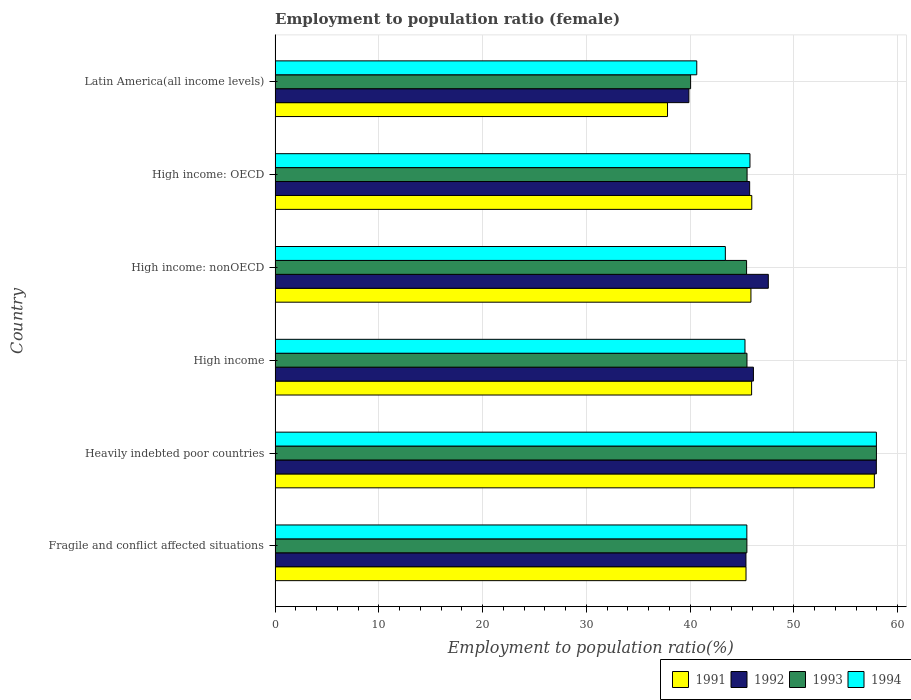How many different coloured bars are there?
Make the answer very short. 4. Are the number of bars on each tick of the Y-axis equal?
Your answer should be compact. Yes. How many bars are there on the 3rd tick from the bottom?
Ensure brevity in your answer.  4. What is the label of the 5th group of bars from the top?
Ensure brevity in your answer.  Heavily indebted poor countries. In how many cases, is the number of bars for a given country not equal to the number of legend labels?
Provide a short and direct response. 0. What is the employment to population ratio in 1992 in High income?
Give a very brief answer. 46.1. Across all countries, what is the maximum employment to population ratio in 1993?
Provide a succinct answer. 57.96. Across all countries, what is the minimum employment to population ratio in 1993?
Keep it short and to the point. 40.05. In which country was the employment to population ratio in 1992 maximum?
Your answer should be compact. Heavily indebted poor countries. In which country was the employment to population ratio in 1993 minimum?
Offer a very short reply. Latin America(all income levels). What is the total employment to population ratio in 1992 in the graph?
Offer a terse response. 282.61. What is the difference between the employment to population ratio in 1993 in High income and that in High income: OECD?
Give a very brief answer. -0.01. What is the difference between the employment to population ratio in 1993 in Latin America(all income levels) and the employment to population ratio in 1991 in Fragile and conflict affected situations?
Your answer should be very brief. -5.34. What is the average employment to population ratio in 1991 per country?
Provide a succinct answer. 46.45. What is the difference between the employment to population ratio in 1991 and employment to population ratio in 1992 in High income?
Offer a terse response. -0.17. What is the ratio of the employment to population ratio in 1991 in Fragile and conflict affected situations to that in Latin America(all income levels)?
Your response must be concise. 1.2. What is the difference between the highest and the second highest employment to population ratio in 1991?
Provide a short and direct response. 11.81. What is the difference between the highest and the lowest employment to population ratio in 1993?
Your answer should be compact. 17.91. In how many countries, is the employment to population ratio in 1992 greater than the average employment to population ratio in 1992 taken over all countries?
Offer a terse response. 2. Is it the case that in every country, the sum of the employment to population ratio in 1992 and employment to population ratio in 1991 is greater than the sum of employment to population ratio in 1993 and employment to population ratio in 1994?
Provide a succinct answer. No. What does the 1st bar from the top in Heavily indebted poor countries represents?
Offer a very short reply. 1994. What does the 2nd bar from the bottom in Fragile and conflict affected situations represents?
Provide a succinct answer. 1992. How many bars are there?
Your response must be concise. 24. Are all the bars in the graph horizontal?
Give a very brief answer. Yes. How many countries are there in the graph?
Ensure brevity in your answer.  6. Are the values on the major ticks of X-axis written in scientific E-notation?
Offer a terse response. No. Does the graph contain any zero values?
Provide a succinct answer. No. Does the graph contain grids?
Provide a short and direct response. Yes. Where does the legend appear in the graph?
Your answer should be very brief. Bottom right. How many legend labels are there?
Give a very brief answer. 4. How are the legend labels stacked?
Ensure brevity in your answer.  Horizontal. What is the title of the graph?
Offer a very short reply. Employment to population ratio (female). What is the Employment to population ratio(%) of 1991 in Fragile and conflict affected situations?
Offer a very short reply. 45.39. What is the Employment to population ratio(%) of 1992 in Fragile and conflict affected situations?
Offer a very short reply. 45.38. What is the Employment to population ratio(%) in 1993 in Fragile and conflict affected situations?
Make the answer very short. 45.48. What is the Employment to population ratio(%) in 1994 in Fragile and conflict affected situations?
Make the answer very short. 45.47. What is the Employment to population ratio(%) in 1991 in Heavily indebted poor countries?
Provide a short and direct response. 57.76. What is the Employment to population ratio(%) in 1992 in Heavily indebted poor countries?
Make the answer very short. 57.95. What is the Employment to population ratio(%) of 1993 in Heavily indebted poor countries?
Offer a very short reply. 57.96. What is the Employment to population ratio(%) of 1994 in Heavily indebted poor countries?
Offer a very short reply. 57.96. What is the Employment to population ratio(%) in 1991 in High income?
Your answer should be very brief. 45.93. What is the Employment to population ratio(%) of 1992 in High income?
Your response must be concise. 46.1. What is the Employment to population ratio(%) in 1993 in High income?
Keep it short and to the point. 45.48. What is the Employment to population ratio(%) of 1994 in High income?
Your answer should be very brief. 45.29. What is the Employment to population ratio(%) in 1991 in High income: nonOECD?
Make the answer very short. 45.86. What is the Employment to population ratio(%) in 1992 in High income: nonOECD?
Offer a very short reply. 47.54. What is the Employment to population ratio(%) in 1993 in High income: nonOECD?
Offer a terse response. 45.44. What is the Employment to population ratio(%) in 1994 in High income: nonOECD?
Your answer should be compact. 43.4. What is the Employment to population ratio(%) of 1991 in High income: OECD?
Give a very brief answer. 45.95. What is the Employment to population ratio(%) of 1992 in High income: OECD?
Your answer should be compact. 45.74. What is the Employment to population ratio(%) of 1993 in High income: OECD?
Keep it short and to the point. 45.49. What is the Employment to population ratio(%) in 1994 in High income: OECD?
Offer a terse response. 45.77. What is the Employment to population ratio(%) of 1991 in Latin America(all income levels)?
Provide a succinct answer. 37.82. What is the Employment to population ratio(%) in 1992 in Latin America(all income levels)?
Your answer should be compact. 39.89. What is the Employment to population ratio(%) in 1993 in Latin America(all income levels)?
Provide a succinct answer. 40.05. What is the Employment to population ratio(%) in 1994 in Latin America(all income levels)?
Your response must be concise. 40.64. Across all countries, what is the maximum Employment to population ratio(%) of 1991?
Offer a terse response. 57.76. Across all countries, what is the maximum Employment to population ratio(%) in 1992?
Offer a terse response. 57.95. Across all countries, what is the maximum Employment to population ratio(%) in 1993?
Offer a terse response. 57.96. Across all countries, what is the maximum Employment to population ratio(%) in 1994?
Your answer should be compact. 57.96. Across all countries, what is the minimum Employment to population ratio(%) in 1991?
Your answer should be compact. 37.82. Across all countries, what is the minimum Employment to population ratio(%) of 1992?
Provide a short and direct response. 39.89. Across all countries, what is the minimum Employment to population ratio(%) of 1993?
Your answer should be very brief. 40.05. Across all countries, what is the minimum Employment to population ratio(%) in 1994?
Ensure brevity in your answer.  40.64. What is the total Employment to population ratio(%) in 1991 in the graph?
Provide a succinct answer. 278.72. What is the total Employment to population ratio(%) in 1992 in the graph?
Provide a short and direct response. 282.61. What is the total Employment to population ratio(%) in 1993 in the graph?
Your answer should be very brief. 279.91. What is the total Employment to population ratio(%) in 1994 in the graph?
Offer a very short reply. 278.53. What is the difference between the Employment to population ratio(%) of 1991 in Fragile and conflict affected situations and that in Heavily indebted poor countries?
Offer a very short reply. -12.37. What is the difference between the Employment to population ratio(%) in 1992 in Fragile and conflict affected situations and that in Heavily indebted poor countries?
Your response must be concise. -12.57. What is the difference between the Employment to population ratio(%) in 1993 in Fragile and conflict affected situations and that in Heavily indebted poor countries?
Give a very brief answer. -12.48. What is the difference between the Employment to population ratio(%) in 1994 in Fragile and conflict affected situations and that in Heavily indebted poor countries?
Offer a very short reply. -12.49. What is the difference between the Employment to population ratio(%) of 1991 in Fragile and conflict affected situations and that in High income?
Offer a terse response. -0.54. What is the difference between the Employment to population ratio(%) of 1992 in Fragile and conflict affected situations and that in High income?
Offer a very short reply. -0.72. What is the difference between the Employment to population ratio(%) in 1993 in Fragile and conflict affected situations and that in High income?
Provide a short and direct response. -0.01. What is the difference between the Employment to population ratio(%) in 1994 in Fragile and conflict affected situations and that in High income?
Give a very brief answer. 0.18. What is the difference between the Employment to population ratio(%) of 1991 in Fragile and conflict affected situations and that in High income: nonOECD?
Offer a very short reply. -0.47. What is the difference between the Employment to population ratio(%) in 1992 in Fragile and conflict affected situations and that in High income: nonOECD?
Your response must be concise. -2.16. What is the difference between the Employment to population ratio(%) in 1993 in Fragile and conflict affected situations and that in High income: nonOECD?
Your answer should be very brief. 0.03. What is the difference between the Employment to population ratio(%) of 1994 in Fragile and conflict affected situations and that in High income: nonOECD?
Keep it short and to the point. 2.07. What is the difference between the Employment to population ratio(%) of 1991 in Fragile and conflict affected situations and that in High income: OECD?
Give a very brief answer. -0.56. What is the difference between the Employment to population ratio(%) of 1992 in Fragile and conflict affected situations and that in High income: OECD?
Ensure brevity in your answer.  -0.36. What is the difference between the Employment to population ratio(%) of 1993 in Fragile and conflict affected situations and that in High income: OECD?
Offer a very short reply. -0.02. What is the difference between the Employment to population ratio(%) in 1994 in Fragile and conflict affected situations and that in High income: OECD?
Give a very brief answer. -0.3. What is the difference between the Employment to population ratio(%) in 1991 in Fragile and conflict affected situations and that in Latin America(all income levels)?
Provide a succinct answer. 7.57. What is the difference between the Employment to population ratio(%) in 1992 in Fragile and conflict affected situations and that in Latin America(all income levels)?
Ensure brevity in your answer.  5.5. What is the difference between the Employment to population ratio(%) in 1993 in Fragile and conflict affected situations and that in Latin America(all income levels)?
Give a very brief answer. 5.42. What is the difference between the Employment to population ratio(%) in 1994 in Fragile and conflict affected situations and that in Latin America(all income levels)?
Make the answer very short. 4.83. What is the difference between the Employment to population ratio(%) in 1991 in Heavily indebted poor countries and that in High income?
Your answer should be very brief. 11.83. What is the difference between the Employment to population ratio(%) in 1992 in Heavily indebted poor countries and that in High income?
Your response must be concise. 11.85. What is the difference between the Employment to population ratio(%) in 1993 in Heavily indebted poor countries and that in High income?
Provide a succinct answer. 12.48. What is the difference between the Employment to population ratio(%) in 1994 in Heavily indebted poor countries and that in High income?
Make the answer very short. 12.67. What is the difference between the Employment to population ratio(%) of 1991 in Heavily indebted poor countries and that in High income: nonOECD?
Provide a short and direct response. 11.9. What is the difference between the Employment to population ratio(%) in 1992 in Heavily indebted poor countries and that in High income: nonOECD?
Provide a succinct answer. 10.41. What is the difference between the Employment to population ratio(%) in 1993 in Heavily indebted poor countries and that in High income: nonOECD?
Offer a terse response. 12.52. What is the difference between the Employment to population ratio(%) of 1994 in Heavily indebted poor countries and that in High income: nonOECD?
Offer a terse response. 14.56. What is the difference between the Employment to population ratio(%) in 1991 in Heavily indebted poor countries and that in High income: OECD?
Offer a very short reply. 11.81. What is the difference between the Employment to population ratio(%) of 1992 in Heavily indebted poor countries and that in High income: OECD?
Your answer should be very brief. 12.21. What is the difference between the Employment to population ratio(%) in 1993 in Heavily indebted poor countries and that in High income: OECD?
Provide a short and direct response. 12.47. What is the difference between the Employment to population ratio(%) in 1994 in Heavily indebted poor countries and that in High income: OECD?
Your answer should be very brief. 12.18. What is the difference between the Employment to population ratio(%) of 1991 in Heavily indebted poor countries and that in Latin America(all income levels)?
Offer a very short reply. 19.94. What is the difference between the Employment to population ratio(%) in 1992 in Heavily indebted poor countries and that in Latin America(all income levels)?
Provide a short and direct response. 18.07. What is the difference between the Employment to population ratio(%) in 1993 in Heavily indebted poor countries and that in Latin America(all income levels)?
Your answer should be very brief. 17.91. What is the difference between the Employment to population ratio(%) of 1994 in Heavily indebted poor countries and that in Latin America(all income levels)?
Make the answer very short. 17.31. What is the difference between the Employment to population ratio(%) of 1991 in High income and that in High income: nonOECD?
Your response must be concise. 0.07. What is the difference between the Employment to population ratio(%) of 1992 in High income and that in High income: nonOECD?
Provide a short and direct response. -1.44. What is the difference between the Employment to population ratio(%) in 1993 in High income and that in High income: nonOECD?
Your response must be concise. 0.04. What is the difference between the Employment to population ratio(%) of 1994 in High income and that in High income: nonOECD?
Provide a short and direct response. 1.89. What is the difference between the Employment to population ratio(%) in 1991 in High income and that in High income: OECD?
Provide a short and direct response. -0.02. What is the difference between the Employment to population ratio(%) of 1992 in High income and that in High income: OECD?
Your answer should be compact. 0.36. What is the difference between the Employment to population ratio(%) of 1993 in High income and that in High income: OECD?
Keep it short and to the point. -0.01. What is the difference between the Employment to population ratio(%) in 1994 in High income and that in High income: OECD?
Your answer should be very brief. -0.48. What is the difference between the Employment to population ratio(%) in 1991 in High income and that in Latin America(all income levels)?
Ensure brevity in your answer.  8.11. What is the difference between the Employment to population ratio(%) in 1992 in High income and that in Latin America(all income levels)?
Provide a succinct answer. 6.22. What is the difference between the Employment to population ratio(%) of 1993 in High income and that in Latin America(all income levels)?
Ensure brevity in your answer.  5.43. What is the difference between the Employment to population ratio(%) of 1994 in High income and that in Latin America(all income levels)?
Ensure brevity in your answer.  4.65. What is the difference between the Employment to population ratio(%) of 1991 in High income: nonOECD and that in High income: OECD?
Your answer should be compact. -0.08. What is the difference between the Employment to population ratio(%) of 1992 in High income: nonOECD and that in High income: OECD?
Provide a short and direct response. 1.8. What is the difference between the Employment to population ratio(%) of 1993 in High income: nonOECD and that in High income: OECD?
Provide a succinct answer. -0.05. What is the difference between the Employment to population ratio(%) of 1994 in High income: nonOECD and that in High income: OECD?
Provide a short and direct response. -2.37. What is the difference between the Employment to population ratio(%) in 1991 in High income: nonOECD and that in Latin America(all income levels)?
Give a very brief answer. 8.04. What is the difference between the Employment to population ratio(%) in 1992 in High income: nonOECD and that in Latin America(all income levels)?
Offer a very short reply. 7.65. What is the difference between the Employment to population ratio(%) of 1993 in High income: nonOECD and that in Latin America(all income levels)?
Ensure brevity in your answer.  5.39. What is the difference between the Employment to population ratio(%) in 1994 in High income: nonOECD and that in Latin America(all income levels)?
Your answer should be compact. 2.75. What is the difference between the Employment to population ratio(%) of 1991 in High income: OECD and that in Latin America(all income levels)?
Ensure brevity in your answer.  8.12. What is the difference between the Employment to population ratio(%) in 1992 in High income: OECD and that in Latin America(all income levels)?
Make the answer very short. 5.86. What is the difference between the Employment to population ratio(%) of 1993 in High income: OECD and that in Latin America(all income levels)?
Your answer should be very brief. 5.44. What is the difference between the Employment to population ratio(%) of 1994 in High income: OECD and that in Latin America(all income levels)?
Your answer should be compact. 5.13. What is the difference between the Employment to population ratio(%) in 1991 in Fragile and conflict affected situations and the Employment to population ratio(%) in 1992 in Heavily indebted poor countries?
Ensure brevity in your answer.  -12.56. What is the difference between the Employment to population ratio(%) of 1991 in Fragile and conflict affected situations and the Employment to population ratio(%) of 1993 in Heavily indebted poor countries?
Your response must be concise. -12.57. What is the difference between the Employment to population ratio(%) of 1991 in Fragile and conflict affected situations and the Employment to population ratio(%) of 1994 in Heavily indebted poor countries?
Make the answer very short. -12.57. What is the difference between the Employment to population ratio(%) of 1992 in Fragile and conflict affected situations and the Employment to population ratio(%) of 1993 in Heavily indebted poor countries?
Provide a succinct answer. -12.58. What is the difference between the Employment to population ratio(%) of 1992 in Fragile and conflict affected situations and the Employment to population ratio(%) of 1994 in Heavily indebted poor countries?
Offer a very short reply. -12.57. What is the difference between the Employment to population ratio(%) in 1993 in Fragile and conflict affected situations and the Employment to population ratio(%) in 1994 in Heavily indebted poor countries?
Your answer should be very brief. -12.48. What is the difference between the Employment to population ratio(%) of 1991 in Fragile and conflict affected situations and the Employment to population ratio(%) of 1992 in High income?
Your response must be concise. -0.71. What is the difference between the Employment to population ratio(%) of 1991 in Fragile and conflict affected situations and the Employment to population ratio(%) of 1993 in High income?
Ensure brevity in your answer.  -0.09. What is the difference between the Employment to population ratio(%) in 1991 in Fragile and conflict affected situations and the Employment to population ratio(%) in 1994 in High income?
Provide a short and direct response. 0.1. What is the difference between the Employment to population ratio(%) of 1992 in Fragile and conflict affected situations and the Employment to population ratio(%) of 1993 in High income?
Your response must be concise. -0.1. What is the difference between the Employment to population ratio(%) in 1992 in Fragile and conflict affected situations and the Employment to population ratio(%) in 1994 in High income?
Ensure brevity in your answer.  0.09. What is the difference between the Employment to population ratio(%) in 1993 in Fragile and conflict affected situations and the Employment to population ratio(%) in 1994 in High income?
Offer a terse response. 0.18. What is the difference between the Employment to population ratio(%) in 1991 in Fragile and conflict affected situations and the Employment to population ratio(%) in 1992 in High income: nonOECD?
Your response must be concise. -2.15. What is the difference between the Employment to population ratio(%) in 1991 in Fragile and conflict affected situations and the Employment to population ratio(%) in 1993 in High income: nonOECD?
Make the answer very short. -0.05. What is the difference between the Employment to population ratio(%) in 1991 in Fragile and conflict affected situations and the Employment to population ratio(%) in 1994 in High income: nonOECD?
Offer a terse response. 1.99. What is the difference between the Employment to population ratio(%) in 1992 in Fragile and conflict affected situations and the Employment to population ratio(%) in 1993 in High income: nonOECD?
Make the answer very short. -0.06. What is the difference between the Employment to population ratio(%) of 1992 in Fragile and conflict affected situations and the Employment to population ratio(%) of 1994 in High income: nonOECD?
Give a very brief answer. 1.99. What is the difference between the Employment to population ratio(%) of 1993 in Fragile and conflict affected situations and the Employment to population ratio(%) of 1994 in High income: nonOECD?
Offer a terse response. 2.08. What is the difference between the Employment to population ratio(%) in 1991 in Fragile and conflict affected situations and the Employment to population ratio(%) in 1992 in High income: OECD?
Offer a terse response. -0.35. What is the difference between the Employment to population ratio(%) in 1991 in Fragile and conflict affected situations and the Employment to population ratio(%) in 1993 in High income: OECD?
Provide a short and direct response. -0.1. What is the difference between the Employment to population ratio(%) of 1991 in Fragile and conflict affected situations and the Employment to population ratio(%) of 1994 in High income: OECD?
Your response must be concise. -0.38. What is the difference between the Employment to population ratio(%) of 1992 in Fragile and conflict affected situations and the Employment to population ratio(%) of 1993 in High income: OECD?
Give a very brief answer. -0.11. What is the difference between the Employment to population ratio(%) in 1992 in Fragile and conflict affected situations and the Employment to population ratio(%) in 1994 in High income: OECD?
Ensure brevity in your answer.  -0.39. What is the difference between the Employment to population ratio(%) in 1993 in Fragile and conflict affected situations and the Employment to population ratio(%) in 1994 in High income: OECD?
Give a very brief answer. -0.3. What is the difference between the Employment to population ratio(%) in 1991 in Fragile and conflict affected situations and the Employment to population ratio(%) in 1992 in Latin America(all income levels)?
Your answer should be compact. 5.51. What is the difference between the Employment to population ratio(%) of 1991 in Fragile and conflict affected situations and the Employment to population ratio(%) of 1993 in Latin America(all income levels)?
Offer a terse response. 5.34. What is the difference between the Employment to population ratio(%) in 1991 in Fragile and conflict affected situations and the Employment to population ratio(%) in 1994 in Latin America(all income levels)?
Offer a terse response. 4.75. What is the difference between the Employment to population ratio(%) of 1992 in Fragile and conflict affected situations and the Employment to population ratio(%) of 1993 in Latin America(all income levels)?
Keep it short and to the point. 5.33. What is the difference between the Employment to population ratio(%) of 1992 in Fragile and conflict affected situations and the Employment to population ratio(%) of 1994 in Latin America(all income levels)?
Give a very brief answer. 4.74. What is the difference between the Employment to population ratio(%) of 1993 in Fragile and conflict affected situations and the Employment to population ratio(%) of 1994 in Latin America(all income levels)?
Ensure brevity in your answer.  4.83. What is the difference between the Employment to population ratio(%) of 1991 in Heavily indebted poor countries and the Employment to population ratio(%) of 1992 in High income?
Give a very brief answer. 11.66. What is the difference between the Employment to population ratio(%) in 1991 in Heavily indebted poor countries and the Employment to population ratio(%) in 1993 in High income?
Your answer should be compact. 12.28. What is the difference between the Employment to population ratio(%) of 1991 in Heavily indebted poor countries and the Employment to population ratio(%) of 1994 in High income?
Give a very brief answer. 12.47. What is the difference between the Employment to population ratio(%) of 1992 in Heavily indebted poor countries and the Employment to population ratio(%) of 1993 in High income?
Your response must be concise. 12.47. What is the difference between the Employment to population ratio(%) in 1992 in Heavily indebted poor countries and the Employment to population ratio(%) in 1994 in High income?
Offer a terse response. 12.66. What is the difference between the Employment to population ratio(%) in 1993 in Heavily indebted poor countries and the Employment to population ratio(%) in 1994 in High income?
Make the answer very short. 12.67. What is the difference between the Employment to population ratio(%) in 1991 in Heavily indebted poor countries and the Employment to population ratio(%) in 1992 in High income: nonOECD?
Offer a very short reply. 10.22. What is the difference between the Employment to population ratio(%) in 1991 in Heavily indebted poor countries and the Employment to population ratio(%) in 1993 in High income: nonOECD?
Provide a succinct answer. 12.32. What is the difference between the Employment to population ratio(%) of 1991 in Heavily indebted poor countries and the Employment to population ratio(%) of 1994 in High income: nonOECD?
Offer a very short reply. 14.36. What is the difference between the Employment to population ratio(%) of 1992 in Heavily indebted poor countries and the Employment to population ratio(%) of 1993 in High income: nonOECD?
Provide a short and direct response. 12.51. What is the difference between the Employment to population ratio(%) of 1992 in Heavily indebted poor countries and the Employment to population ratio(%) of 1994 in High income: nonOECD?
Your answer should be compact. 14.55. What is the difference between the Employment to population ratio(%) in 1993 in Heavily indebted poor countries and the Employment to population ratio(%) in 1994 in High income: nonOECD?
Provide a short and direct response. 14.56. What is the difference between the Employment to population ratio(%) of 1991 in Heavily indebted poor countries and the Employment to population ratio(%) of 1992 in High income: OECD?
Provide a succinct answer. 12.02. What is the difference between the Employment to population ratio(%) in 1991 in Heavily indebted poor countries and the Employment to population ratio(%) in 1993 in High income: OECD?
Your answer should be very brief. 12.27. What is the difference between the Employment to population ratio(%) in 1991 in Heavily indebted poor countries and the Employment to population ratio(%) in 1994 in High income: OECD?
Your answer should be compact. 11.99. What is the difference between the Employment to population ratio(%) of 1992 in Heavily indebted poor countries and the Employment to population ratio(%) of 1993 in High income: OECD?
Provide a succinct answer. 12.46. What is the difference between the Employment to population ratio(%) of 1992 in Heavily indebted poor countries and the Employment to population ratio(%) of 1994 in High income: OECD?
Your response must be concise. 12.18. What is the difference between the Employment to population ratio(%) in 1993 in Heavily indebted poor countries and the Employment to population ratio(%) in 1994 in High income: OECD?
Give a very brief answer. 12.19. What is the difference between the Employment to population ratio(%) in 1991 in Heavily indebted poor countries and the Employment to population ratio(%) in 1992 in Latin America(all income levels)?
Make the answer very short. 17.88. What is the difference between the Employment to population ratio(%) in 1991 in Heavily indebted poor countries and the Employment to population ratio(%) in 1993 in Latin America(all income levels)?
Your response must be concise. 17.71. What is the difference between the Employment to population ratio(%) in 1991 in Heavily indebted poor countries and the Employment to population ratio(%) in 1994 in Latin America(all income levels)?
Provide a short and direct response. 17.12. What is the difference between the Employment to population ratio(%) in 1992 in Heavily indebted poor countries and the Employment to population ratio(%) in 1993 in Latin America(all income levels)?
Offer a terse response. 17.9. What is the difference between the Employment to population ratio(%) in 1992 in Heavily indebted poor countries and the Employment to population ratio(%) in 1994 in Latin America(all income levels)?
Provide a short and direct response. 17.31. What is the difference between the Employment to population ratio(%) of 1993 in Heavily indebted poor countries and the Employment to population ratio(%) of 1994 in Latin America(all income levels)?
Your answer should be compact. 17.32. What is the difference between the Employment to population ratio(%) in 1991 in High income and the Employment to population ratio(%) in 1992 in High income: nonOECD?
Your answer should be compact. -1.61. What is the difference between the Employment to population ratio(%) in 1991 in High income and the Employment to population ratio(%) in 1993 in High income: nonOECD?
Offer a very short reply. 0.49. What is the difference between the Employment to population ratio(%) in 1991 in High income and the Employment to population ratio(%) in 1994 in High income: nonOECD?
Offer a terse response. 2.53. What is the difference between the Employment to population ratio(%) in 1992 in High income and the Employment to population ratio(%) in 1993 in High income: nonOECD?
Make the answer very short. 0.66. What is the difference between the Employment to population ratio(%) of 1992 in High income and the Employment to population ratio(%) of 1994 in High income: nonOECD?
Your answer should be very brief. 2.71. What is the difference between the Employment to population ratio(%) of 1993 in High income and the Employment to population ratio(%) of 1994 in High income: nonOECD?
Your response must be concise. 2.09. What is the difference between the Employment to population ratio(%) in 1991 in High income and the Employment to population ratio(%) in 1992 in High income: OECD?
Offer a very short reply. 0.19. What is the difference between the Employment to population ratio(%) in 1991 in High income and the Employment to population ratio(%) in 1993 in High income: OECD?
Make the answer very short. 0.44. What is the difference between the Employment to population ratio(%) in 1991 in High income and the Employment to population ratio(%) in 1994 in High income: OECD?
Offer a terse response. 0.16. What is the difference between the Employment to population ratio(%) in 1992 in High income and the Employment to population ratio(%) in 1993 in High income: OECD?
Your response must be concise. 0.61. What is the difference between the Employment to population ratio(%) of 1992 in High income and the Employment to population ratio(%) of 1994 in High income: OECD?
Your response must be concise. 0.33. What is the difference between the Employment to population ratio(%) in 1993 in High income and the Employment to population ratio(%) in 1994 in High income: OECD?
Offer a terse response. -0.29. What is the difference between the Employment to population ratio(%) in 1991 in High income and the Employment to population ratio(%) in 1992 in Latin America(all income levels)?
Offer a terse response. 6.05. What is the difference between the Employment to population ratio(%) in 1991 in High income and the Employment to population ratio(%) in 1993 in Latin America(all income levels)?
Offer a terse response. 5.88. What is the difference between the Employment to population ratio(%) of 1991 in High income and the Employment to population ratio(%) of 1994 in Latin America(all income levels)?
Offer a terse response. 5.29. What is the difference between the Employment to population ratio(%) of 1992 in High income and the Employment to population ratio(%) of 1993 in Latin America(all income levels)?
Your response must be concise. 6.05. What is the difference between the Employment to population ratio(%) of 1992 in High income and the Employment to population ratio(%) of 1994 in Latin America(all income levels)?
Your response must be concise. 5.46. What is the difference between the Employment to population ratio(%) in 1993 in High income and the Employment to population ratio(%) in 1994 in Latin America(all income levels)?
Provide a succinct answer. 4.84. What is the difference between the Employment to population ratio(%) in 1991 in High income: nonOECD and the Employment to population ratio(%) in 1992 in High income: OECD?
Your response must be concise. 0.12. What is the difference between the Employment to population ratio(%) of 1991 in High income: nonOECD and the Employment to population ratio(%) of 1993 in High income: OECD?
Your response must be concise. 0.37. What is the difference between the Employment to population ratio(%) of 1991 in High income: nonOECD and the Employment to population ratio(%) of 1994 in High income: OECD?
Provide a short and direct response. 0.09. What is the difference between the Employment to population ratio(%) of 1992 in High income: nonOECD and the Employment to population ratio(%) of 1993 in High income: OECD?
Offer a terse response. 2.05. What is the difference between the Employment to population ratio(%) of 1992 in High income: nonOECD and the Employment to population ratio(%) of 1994 in High income: OECD?
Offer a terse response. 1.77. What is the difference between the Employment to population ratio(%) in 1993 in High income: nonOECD and the Employment to population ratio(%) in 1994 in High income: OECD?
Keep it short and to the point. -0.33. What is the difference between the Employment to population ratio(%) in 1991 in High income: nonOECD and the Employment to population ratio(%) in 1992 in Latin America(all income levels)?
Ensure brevity in your answer.  5.98. What is the difference between the Employment to population ratio(%) in 1991 in High income: nonOECD and the Employment to population ratio(%) in 1993 in Latin America(all income levels)?
Provide a succinct answer. 5.81. What is the difference between the Employment to population ratio(%) in 1991 in High income: nonOECD and the Employment to population ratio(%) in 1994 in Latin America(all income levels)?
Provide a succinct answer. 5.22. What is the difference between the Employment to population ratio(%) in 1992 in High income: nonOECD and the Employment to population ratio(%) in 1993 in Latin America(all income levels)?
Offer a terse response. 7.49. What is the difference between the Employment to population ratio(%) of 1992 in High income: nonOECD and the Employment to population ratio(%) of 1994 in Latin America(all income levels)?
Offer a very short reply. 6.9. What is the difference between the Employment to population ratio(%) of 1993 in High income: nonOECD and the Employment to population ratio(%) of 1994 in Latin America(all income levels)?
Your answer should be very brief. 4.8. What is the difference between the Employment to population ratio(%) of 1991 in High income: OECD and the Employment to population ratio(%) of 1992 in Latin America(all income levels)?
Your response must be concise. 6.06. What is the difference between the Employment to population ratio(%) of 1991 in High income: OECD and the Employment to population ratio(%) of 1993 in Latin America(all income levels)?
Offer a very short reply. 5.9. What is the difference between the Employment to population ratio(%) of 1991 in High income: OECD and the Employment to population ratio(%) of 1994 in Latin America(all income levels)?
Keep it short and to the point. 5.3. What is the difference between the Employment to population ratio(%) in 1992 in High income: OECD and the Employment to population ratio(%) in 1993 in Latin America(all income levels)?
Provide a succinct answer. 5.69. What is the difference between the Employment to population ratio(%) in 1992 in High income: OECD and the Employment to population ratio(%) in 1994 in Latin America(all income levels)?
Provide a short and direct response. 5.1. What is the difference between the Employment to population ratio(%) of 1993 in High income: OECD and the Employment to population ratio(%) of 1994 in Latin America(all income levels)?
Make the answer very short. 4.85. What is the average Employment to population ratio(%) in 1991 per country?
Provide a short and direct response. 46.45. What is the average Employment to population ratio(%) of 1992 per country?
Your answer should be compact. 47.1. What is the average Employment to population ratio(%) in 1993 per country?
Your response must be concise. 46.65. What is the average Employment to population ratio(%) in 1994 per country?
Provide a succinct answer. 46.42. What is the difference between the Employment to population ratio(%) of 1991 and Employment to population ratio(%) of 1992 in Fragile and conflict affected situations?
Your response must be concise. 0.01. What is the difference between the Employment to population ratio(%) in 1991 and Employment to population ratio(%) in 1993 in Fragile and conflict affected situations?
Keep it short and to the point. -0.08. What is the difference between the Employment to population ratio(%) in 1991 and Employment to population ratio(%) in 1994 in Fragile and conflict affected situations?
Make the answer very short. -0.08. What is the difference between the Employment to population ratio(%) of 1992 and Employment to population ratio(%) of 1993 in Fragile and conflict affected situations?
Your answer should be compact. -0.09. What is the difference between the Employment to population ratio(%) of 1992 and Employment to population ratio(%) of 1994 in Fragile and conflict affected situations?
Your response must be concise. -0.09. What is the difference between the Employment to population ratio(%) of 1993 and Employment to population ratio(%) of 1994 in Fragile and conflict affected situations?
Your answer should be very brief. 0.01. What is the difference between the Employment to population ratio(%) of 1991 and Employment to population ratio(%) of 1992 in Heavily indebted poor countries?
Your response must be concise. -0.19. What is the difference between the Employment to population ratio(%) in 1991 and Employment to population ratio(%) in 1993 in Heavily indebted poor countries?
Offer a terse response. -0.2. What is the difference between the Employment to population ratio(%) of 1991 and Employment to population ratio(%) of 1994 in Heavily indebted poor countries?
Your answer should be compact. -0.2. What is the difference between the Employment to population ratio(%) of 1992 and Employment to population ratio(%) of 1993 in Heavily indebted poor countries?
Your answer should be compact. -0.01. What is the difference between the Employment to population ratio(%) in 1992 and Employment to population ratio(%) in 1994 in Heavily indebted poor countries?
Offer a very short reply. -0. What is the difference between the Employment to population ratio(%) in 1993 and Employment to population ratio(%) in 1994 in Heavily indebted poor countries?
Give a very brief answer. 0. What is the difference between the Employment to population ratio(%) of 1991 and Employment to population ratio(%) of 1992 in High income?
Your answer should be very brief. -0.17. What is the difference between the Employment to population ratio(%) in 1991 and Employment to population ratio(%) in 1993 in High income?
Your answer should be very brief. 0.45. What is the difference between the Employment to population ratio(%) in 1991 and Employment to population ratio(%) in 1994 in High income?
Offer a terse response. 0.64. What is the difference between the Employment to population ratio(%) in 1992 and Employment to population ratio(%) in 1993 in High income?
Offer a very short reply. 0.62. What is the difference between the Employment to population ratio(%) of 1992 and Employment to population ratio(%) of 1994 in High income?
Offer a very short reply. 0.81. What is the difference between the Employment to population ratio(%) of 1993 and Employment to population ratio(%) of 1994 in High income?
Keep it short and to the point. 0.19. What is the difference between the Employment to population ratio(%) of 1991 and Employment to population ratio(%) of 1992 in High income: nonOECD?
Your answer should be compact. -1.68. What is the difference between the Employment to population ratio(%) in 1991 and Employment to population ratio(%) in 1993 in High income: nonOECD?
Your answer should be very brief. 0.42. What is the difference between the Employment to population ratio(%) in 1991 and Employment to population ratio(%) in 1994 in High income: nonOECD?
Offer a terse response. 2.47. What is the difference between the Employment to population ratio(%) in 1992 and Employment to population ratio(%) in 1993 in High income: nonOECD?
Make the answer very short. 2.1. What is the difference between the Employment to population ratio(%) of 1992 and Employment to population ratio(%) of 1994 in High income: nonOECD?
Keep it short and to the point. 4.14. What is the difference between the Employment to population ratio(%) in 1993 and Employment to population ratio(%) in 1994 in High income: nonOECD?
Make the answer very short. 2.05. What is the difference between the Employment to population ratio(%) in 1991 and Employment to population ratio(%) in 1992 in High income: OECD?
Provide a succinct answer. 0.21. What is the difference between the Employment to population ratio(%) of 1991 and Employment to population ratio(%) of 1993 in High income: OECD?
Keep it short and to the point. 0.45. What is the difference between the Employment to population ratio(%) of 1991 and Employment to population ratio(%) of 1994 in High income: OECD?
Make the answer very short. 0.17. What is the difference between the Employment to population ratio(%) of 1992 and Employment to population ratio(%) of 1993 in High income: OECD?
Your response must be concise. 0.25. What is the difference between the Employment to population ratio(%) in 1992 and Employment to population ratio(%) in 1994 in High income: OECD?
Make the answer very short. -0.03. What is the difference between the Employment to population ratio(%) in 1993 and Employment to population ratio(%) in 1994 in High income: OECD?
Your response must be concise. -0.28. What is the difference between the Employment to population ratio(%) of 1991 and Employment to population ratio(%) of 1992 in Latin America(all income levels)?
Ensure brevity in your answer.  -2.06. What is the difference between the Employment to population ratio(%) of 1991 and Employment to population ratio(%) of 1993 in Latin America(all income levels)?
Keep it short and to the point. -2.23. What is the difference between the Employment to population ratio(%) in 1991 and Employment to population ratio(%) in 1994 in Latin America(all income levels)?
Your answer should be compact. -2.82. What is the difference between the Employment to population ratio(%) in 1992 and Employment to population ratio(%) in 1993 in Latin America(all income levels)?
Your answer should be compact. -0.17. What is the difference between the Employment to population ratio(%) of 1992 and Employment to population ratio(%) of 1994 in Latin America(all income levels)?
Keep it short and to the point. -0.76. What is the difference between the Employment to population ratio(%) in 1993 and Employment to population ratio(%) in 1994 in Latin America(all income levels)?
Your answer should be compact. -0.59. What is the ratio of the Employment to population ratio(%) in 1991 in Fragile and conflict affected situations to that in Heavily indebted poor countries?
Provide a short and direct response. 0.79. What is the ratio of the Employment to population ratio(%) of 1992 in Fragile and conflict affected situations to that in Heavily indebted poor countries?
Make the answer very short. 0.78. What is the ratio of the Employment to population ratio(%) in 1993 in Fragile and conflict affected situations to that in Heavily indebted poor countries?
Provide a succinct answer. 0.78. What is the ratio of the Employment to population ratio(%) of 1994 in Fragile and conflict affected situations to that in Heavily indebted poor countries?
Your answer should be very brief. 0.78. What is the ratio of the Employment to population ratio(%) of 1992 in Fragile and conflict affected situations to that in High income?
Give a very brief answer. 0.98. What is the ratio of the Employment to population ratio(%) of 1992 in Fragile and conflict affected situations to that in High income: nonOECD?
Your response must be concise. 0.95. What is the ratio of the Employment to population ratio(%) in 1994 in Fragile and conflict affected situations to that in High income: nonOECD?
Keep it short and to the point. 1.05. What is the ratio of the Employment to population ratio(%) in 1991 in Fragile and conflict affected situations to that in High income: OECD?
Keep it short and to the point. 0.99. What is the ratio of the Employment to population ratio(%) in 1993 in Fragile and conflict affected situations to that in High income: OECD?
Keep it short and to the point. 1. What is the ratio of the Employment to population ratio(%) in 1991 in Fragile and conflict affected situations to that in Latin America(all income levels)?
Your answer should be very brief. 1.2. What is the ratio of the Employment to population ratio(%) in 1992 in Fragile and conflict affected situations to that in Latin America(all income levels)?
Keep it short and to the point. 1.14. What is the ratio of the Employment to population ratio(%) in 1993 in Fragile and conflict affected situations to that in Latin America(all income levels)?
Your answer should be compact. 1.14. What is the ratio of the Employment to population ratio(%) of 1994 in Fragile and conflict affected situations to that in Latin America(all income levels)?
Make the answer very short. 1.12. What is the ratio of the Employment to population ratio(%) in 1991 in Heavily indebted poor countries to that in High income?
Give a very brief answer. 1.26. What is the ratio of the Employment to population ratio(%) in 1992 in Heavily indebted poor countries to that in High income?
Provide a short and direct response. 1.26. What is the ratio of the Employment to population ratio(%) of 1993 in Heavily indebted poor countries to that in High income?
Offer a terse response. 1.27. What is the ratio of the Employment to population ratio(%) of 1994 in Heavily indebted poor countries to that in High income?
Ensure brevity in your answer.  1.28. What is the ratio of the Employment to population ratio(%) of 1991 in Heavily indebted poor countries to that in High income: nonOECD?
Keep it short and to the point. 1.26. What is the ratio of the Employment to population ratio(%) of 1992 in Heavily indebted poor countries to that in High income: nonOECD?
Provide a succinct answer. 1.22. What is the ratio of the Employment to population ratio(%) in 1993 in Heavily indebted poor countries to that in High income: nonOECD?
Provide a short and direct response. 1.28. What is the ratio of the Employment to population ratio(%) in 1994 in Heavily indebted poor countries to that in High income: nonOECD?
Provide a succinct answer. 1.34. What is the ratio of the Employment to population ratio(%) of 1991 in Heavily indebted poor countries to that in High income: OECD?
Your answer should be very brief. 1.26. What is the ratio of the Employment to population ratio(%) of 1992 in Heavily indebted poor countries to that in High income: OECD?
Ensure brevity in your answer.  1.27. What is the ratio of the Employment to population ratio(%) of 1993 in Heavily indebted poor countries to that in High income: OECD?
Offer a terse response. 1.27. What is the ratio of the Employment to population ratio(%) in 1994 in Heavily indebted poor countries to that in High income: OECD?
Give a very brief answer. 1.27. What is the ratio of the Employment to population ratio(%) of 1991 in Heavily indebted poor countries to that in Latin America(all income levels)?
Your response must be concise. 1.53. What is the ratio of the Employment to population ratio(%) of 1992 in Heavily indebted poor countries to that in Latin America(all income levels)?
Ensure brevity in your answer.  1.45. What is the ratio of the Employment to population ratio(%) of 1993 in Heavily indebted poor countries to that in Latin America(all income levels)?
Provide a succinct answer. 1.45. What is the ratio of the Employment to population ratio(%) of 1994 in Heavily indebted poor countries to that in Latin America(all income levels)?
Offer a terse response. 1.43. What is the ratio of the Employment to population ratio(%) in 1992 in High income to that in High income: nonOECD?
Give a very brief answer. 0.97. What is the ratio of the Employment to population ratio(%) of 1993 in High income to that in High income: nonOECD?
Provide a short and direct response. 1. What is the ratio of the Employment to population ratio(%) of 1994 in High income to that in High income: nonOECD?
Give a very brief answer. 1.04. What is the ratio of the Employment to population ratio(%) in 1992 in High income to that in High income: OECD?
Offer a terse response. 1.01. What is the ratio of the Employment to population ratio(%) of 1993 in High income to that in High income: OECD?
Provide a succinct answer. 1. What is the ratio of the Employment to population ratio(%) of 1991 in High income to that in Latin America(all income levels)?
Keep it short and to the point. 1.21. What is the ratio of the Employment to population ratio(%) of 1992 in High income to that in Latin America(all income levels)?
Offer a very short reply. 1.16. What is the ratio of the Employment to population ratio(%) in 1993 in High income to that in Latin America(all income levels)?
Your answer should be compact. 1.14. What is the ratio of the Employment to population ratio(%) in 1994 in High income to that in Latin America(all income levels)?
Offer a terse response. 1.11. What is the ratio of the Employment to population ratio(%) in 1992 in High income: nonOECD to that in High income: OECD?
Provide a short and direct response. 1.04. What is the ratio of the Employment to population ratio(%) in 1994 in High income: nonOECD to that in High income: OECD?
Your answer should be compact. 0.95. What is the ratio of the Employment to population ratio(%) of 1991 in High income: nonOECD to that in Latin America(all income levels)?
Your answer should be compact. 1.21. What is the ratio of the Employment to population ratio(%) in 1992 in High income: nonOECD to that in Latin America(all income levels)?
Your response must be concise. 1.19. What is the ratio of the Employment to population ratio(%) in 1993 in High income: nonOECD to that in Latin America(all income levels)?
Offer a very short reply. 1.13. What is the ratio of the Employment to population ratio(%) of 1994 in High income: nonOECD to that in Latin America(all income levels)?
Provide a succinct answer. 1.07. What is the ratio of the Employment to population ratio(%) of 1991 in High income: OECD to that in Latin America(all income levels)?
Give a very brief answer. 1.21. What is the ratio of the Employment to population ratio(%) of 1992 in High income: OECD to that in Latin America(all income levels)?
Keep it short and to the point. 1.15. What is the ratio of the Employment to population ratio(%) in 1993 in High income: OECD to that in Latin America(all income levels)?
Keep it short and to the point. 1.14. What is the ratio of the Employment to population ratio(%) of 1994 in High income: OECD to that in Latin America(all income levels)?
Provide a short and direct response. 1.13. What is the difference between the highest and the second highest Employment to population ratio(%) in 1991?
Ensure brevity in your answer.  11.81. What is the difference between the highest and the second highest Employment to population ratio(%) of 1992?
Your answer should be very brief. 10.41. What is the difference between the highest and the second highest Employment to population ratio(%) of 1993?
Provide a short and direct response. 12.47. What is the difference between the highest and the second highest Employment to population ratio(%) in 1994?
Provide a short and direct response. 12.18. What is the difference between the highest and the lowest Employment to population ratio(%) in 1991?
Give a very brief answer. 19.94. What is the difference between the highest and the lowest Employment to population ratio(%) of 1992?
Give a very brief answer. 18.07. What is the difference between the highest and the lowest Employment to population ratio(%) in 1993?
Give a very brief answer. 17.91. What is the difference between the highest and the lowest Employment to population ratio(%) of 1994?
Your answer should be very brief. 17.31. 